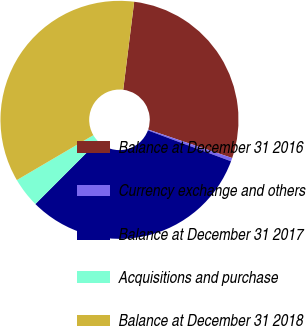Convert chart. <chart><loc_0><loc_0><loc_500><loc_500><pie_chart><fcel>Balance at December 31 2016<fcel>Currency exchange and others<fcel>Balance at December 31 2017<fcel>Acquisitions and purchase<fcel>Balance at December 31 2018<nl><fcel>28.23%<fcel>0.46%<fcel>31.83%<fcel>4.06%<fcel>35.42%<nl></chart> 